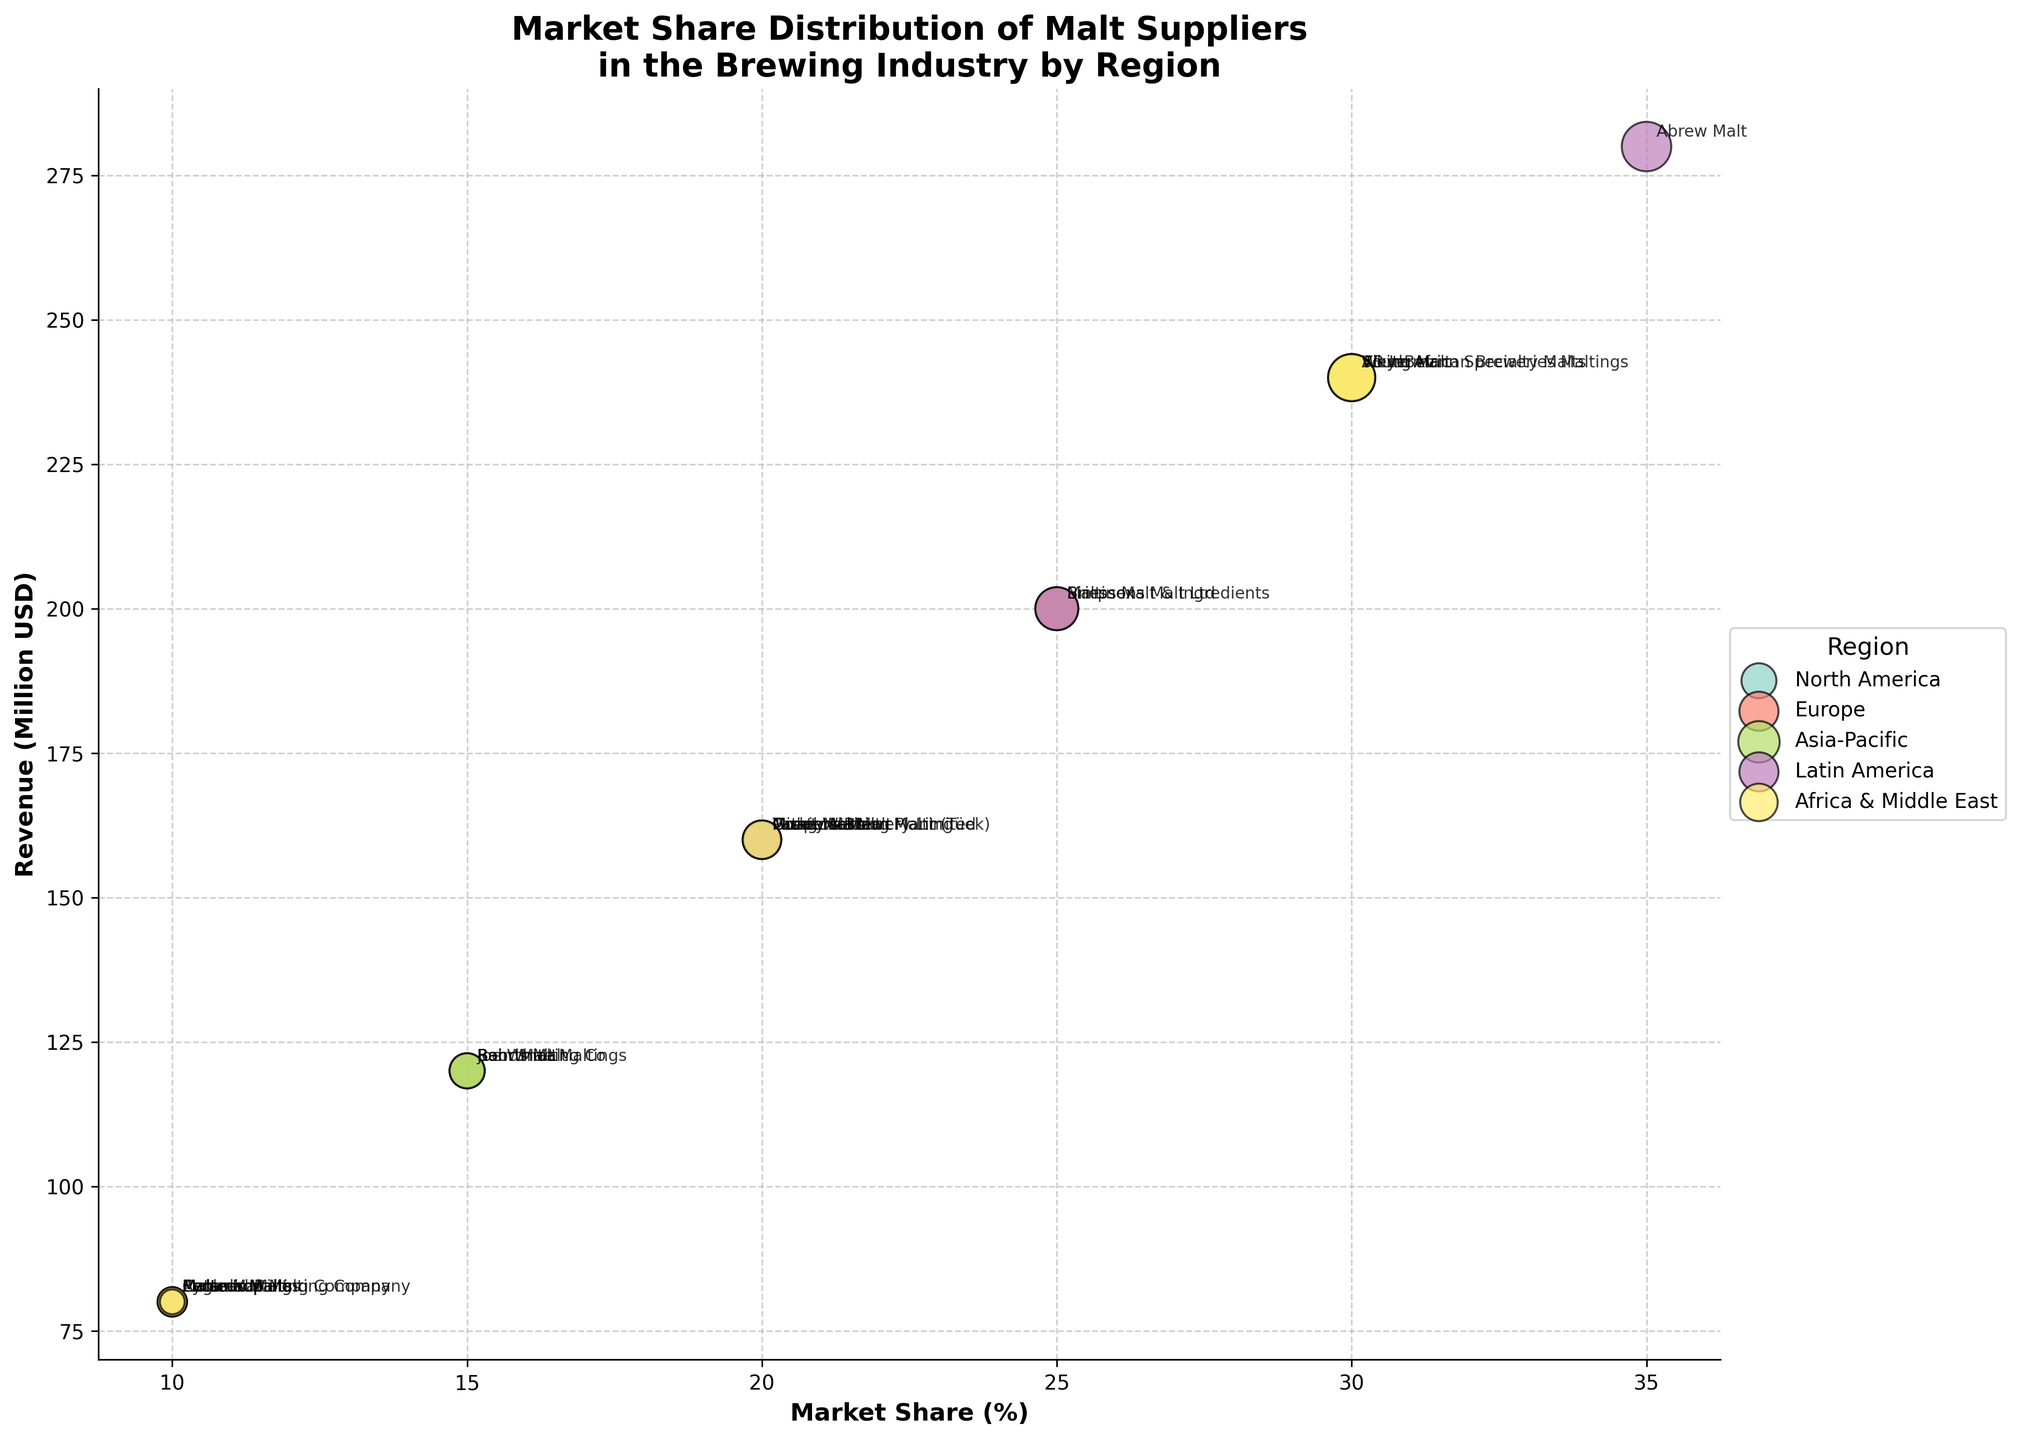What is the title of the figure? The title of the figure is written at the top and provides an overall idea of what the plot represents. It reads "Market Share Distribution of Malt Suppliers in the Brewing Industry by Region."
Answer: Market Share Distribution of Malt Suppliers in the Brewing Industry by Region Which supplier has the highest market share in Latin America? The bubbles on the chart corresponding to Latin America are color-coded. By looking at the positions and labels of these bubbles, the supplier with the highest market share percentage can be identified. In Latin America, the highest market share is 35% and is attributed to Abrew Malt.
Answer: Abrew Malt What is the number of breweries supplied by Weyermann Specialty Malts? Weyermann Specialty Malts supplies breweries in Europe. By locating this bubble and reading its label, the number associated with the size of the bubble represents the number of breweries supplied. For Weyermann Specialty Malts, it's 180.
Answer: 180 Which supplier in the Asia-Pacific region has the highest revenue? Bubbles representing suppliers in the Asia-Pacific region are examined. The bubble with the highest position along the Revenue (Million USD) axis indicates the supplier with the highest revenue. Viking Malt has the highest revenue in the Asia-Pacific at 240 million USD.
Answer: Viking Malt How does the market share of Briess Malt & Ingredients compare to Malsur in terms of percentage? Locate both bubbles on the chart and observe the market share percentages next to each. Briess Malt & Ingredients has 25%, while Malsur has 10%. A direct comparison shows Briess Malt & Ingredients has a substantially higher market share.
Answer: Briess Malt & Ingredients has a higher market share What is the approximate difference in revenue between Great Western Malting and Muntons Malt? Identify the bubbles for Great Western Malting and Muntons Malt and find their revenue values. Great Western Malting has a revenue of 160 million USD and Muntons Malt likewise has 160 million USD. The approximate difference is 0.
Answer: 0 million USD In North America, which supplier services the fewest number of breweries? In the North America section, compare the bubbles by their sizes which represent the number of breweries supplied. Canada Malting Company supplies the fewest number of breweries at 50.
Answer: Canada Malting Company How many suppliers are present in the Africa & Middle East region? Each bubble represents a supplier. Counting the number of distinct bubbles in the Africa & Middle East region gives the answer. There are 5 suppliers in this region.
Answer: 5 Is the market share of Patagonian Malt greater than, less than, or equal to the market share of Coopers Brewery Limited in Asia-Pacific? Examine the bubbles corresponding to Asia-Pacific for Patagonia Malt and Coopers Brewery Limited. Both have a market share of 20%. Therefore, they are equal.
Answer: Equal Who are the two suppliers with the highest market share in Africa & Middle East and do they have equal market share? Look at the Africa & Middle East section, find the highest market share percentages and compare them. South African Breweries Maltings and AB InBev each have a market share of 30%. They have equal market shares.
Answer: South African Breweries Maltings and AB InBev, equal 